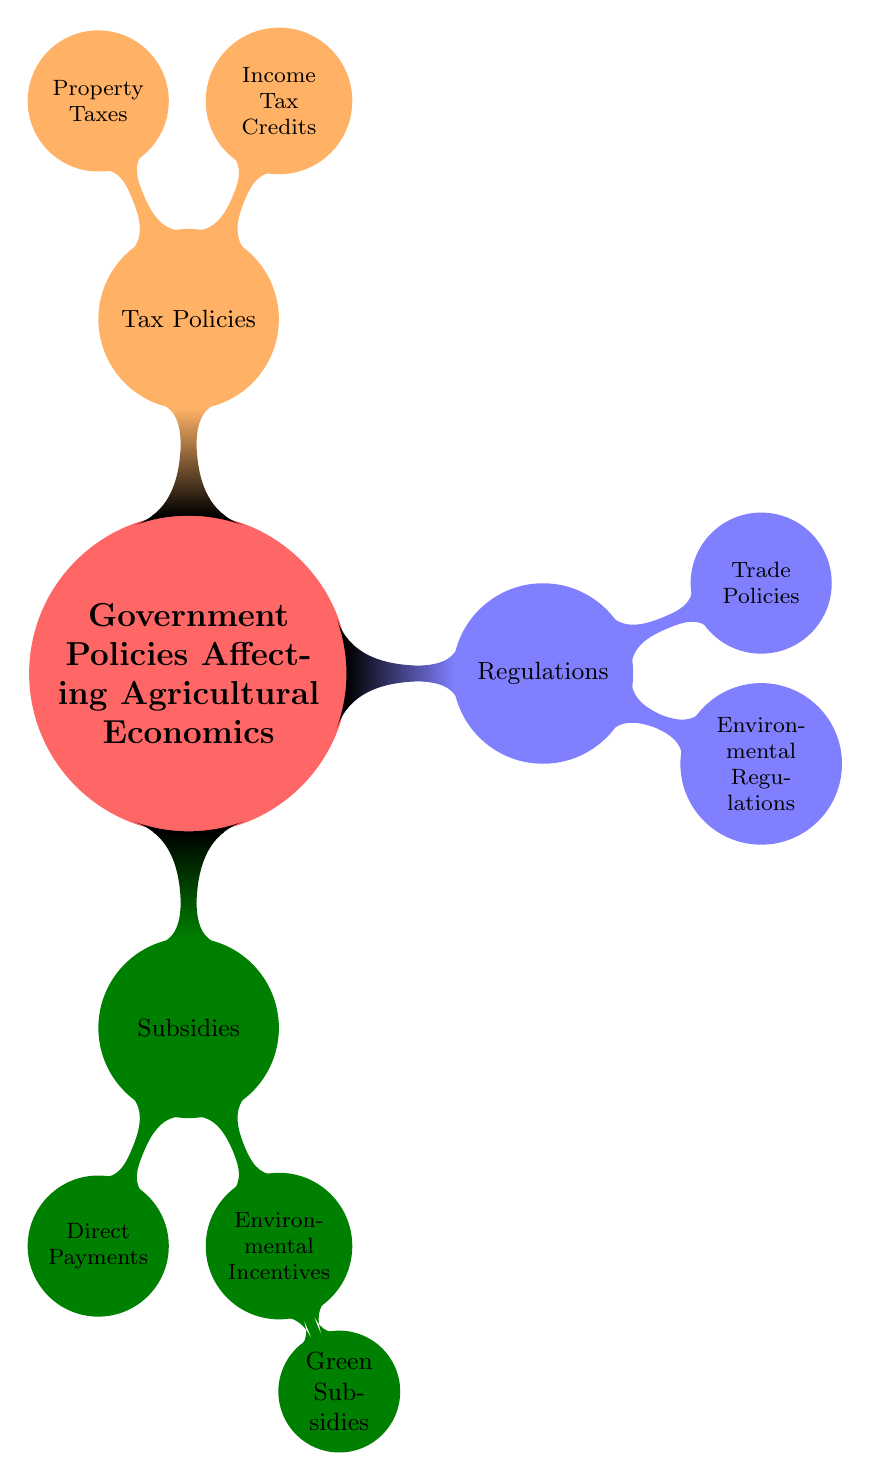What's the main category represented in the diagram? The main category is located at the center of the mind map, labeled "Government Policies Affecting Agricultural Economics."
Answer: Government Policies Affecting Agricultural Economics How many subcategories are directly connected to the main category? Counting the nodes that branch directly from the central node reveals there are three subcategories: Subsidies, Regulations, and Tax Policies.
Answer: 3 What specific program falls under Environmental Incentives? Within the "Environmental Incentives" node, the specific programs listed are "Conservation Stewardship Program" and "Environmental Quality Incentives Program."
Answer: Conservation Stewardship Program, Environmental Quality Incentives Program What type of subsidy is criticized for favoring small farms? The node under "Environmental Incentives" identifies "Green Subsidies" as the type that is criticized for favoring small farms.
Answer: Green Subsidies How does Trade Policies relate to Regulations? Trade Policies is a child node that falls directly under Regulations in the mind map, indicating its relationship as a specific area under the broader category of Regulations.
Answer: Regulations Which tax credit specifically assists small farms? The node under "Income Tax Credits" identifies "Family Farm Tax Credit" as the specific tax credit targeted to assist small farms.
Answer: Family Farm Tax Credit What are the two specific focuses highlighted under Direct Payments? The "Direct Payments" node includes two specific focuses: "Crop-Specific" (which includes Corn and Soybeans) and "Livestock-Specific" (which includes Cattle and Dairy Farms).
Answer: Corn, Soybeans, Cattle, Dairy Farms Where are environmental regulations documented within the diagram? Environmental regulations are clearly listed as a child node under the broader category of Regulations, showing their specific focus within that framework.
Answer: Regulations Which act pertains to water usage regulations? The "Clean Water Act" is specifically mentioned under the "Environmental Regulations" node as pertaining to water usage regulations.
Answer: Clean Water Act 